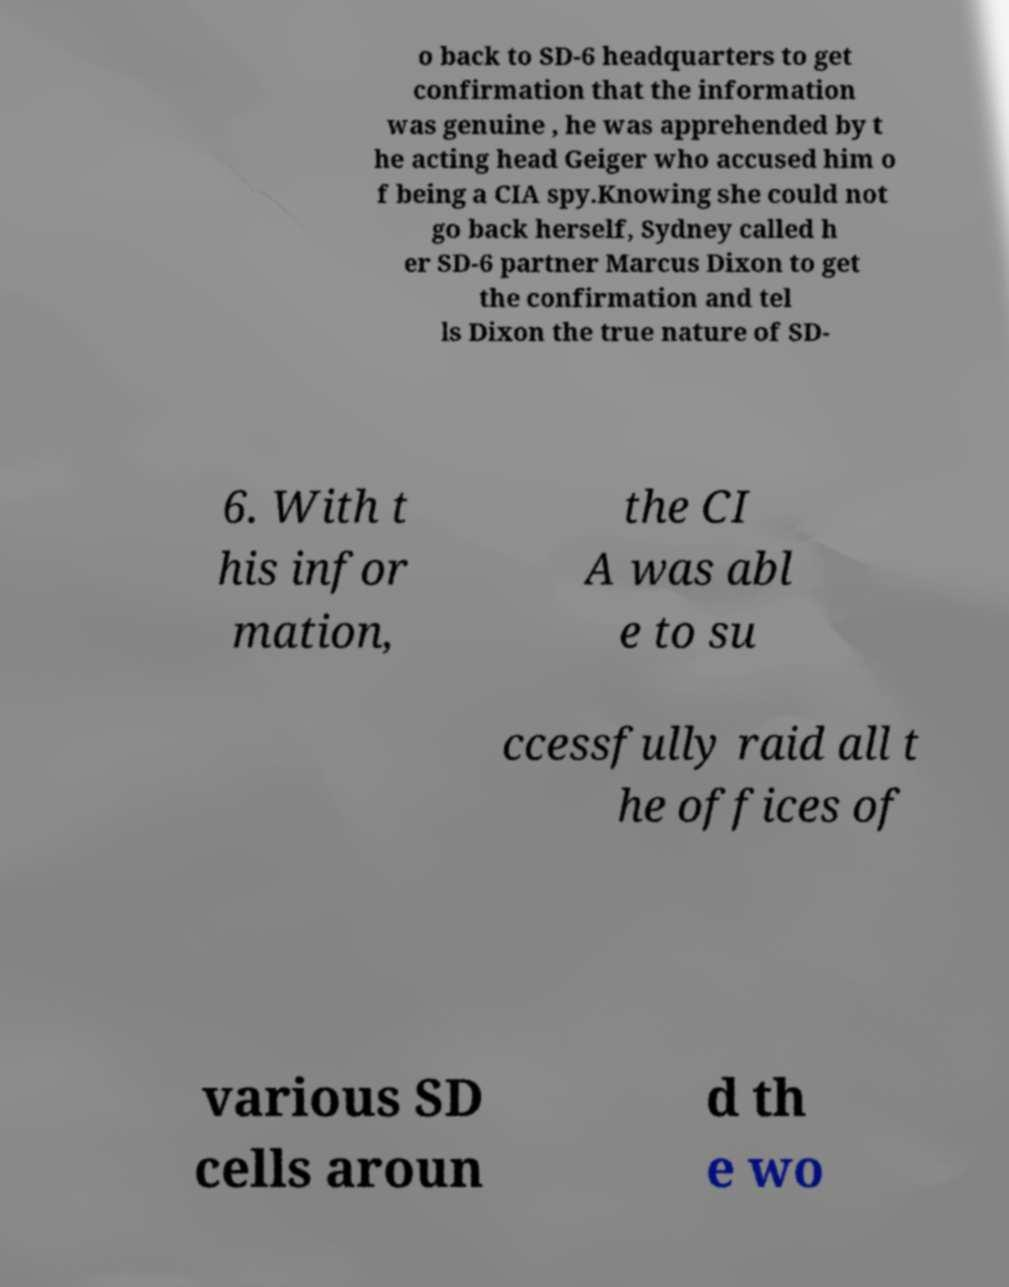What messages or text are displayed in this image? I need them in a readable, typed format. o back to SD-6 headquarters to get confirmation that the information was genuine , he was apprehended by t he acting head Geiger who accused him o f being a CIA spy.Knowing she could not go back herself, Sydney called h er SD-6 partner Marcus Dixon to get the confirmation and tel ls Dixon the true nature of SD- 6. With t his infor mation, the CI A was abl e to su ccessfully raid all t he offices of various SD cells aroun d th e wo 